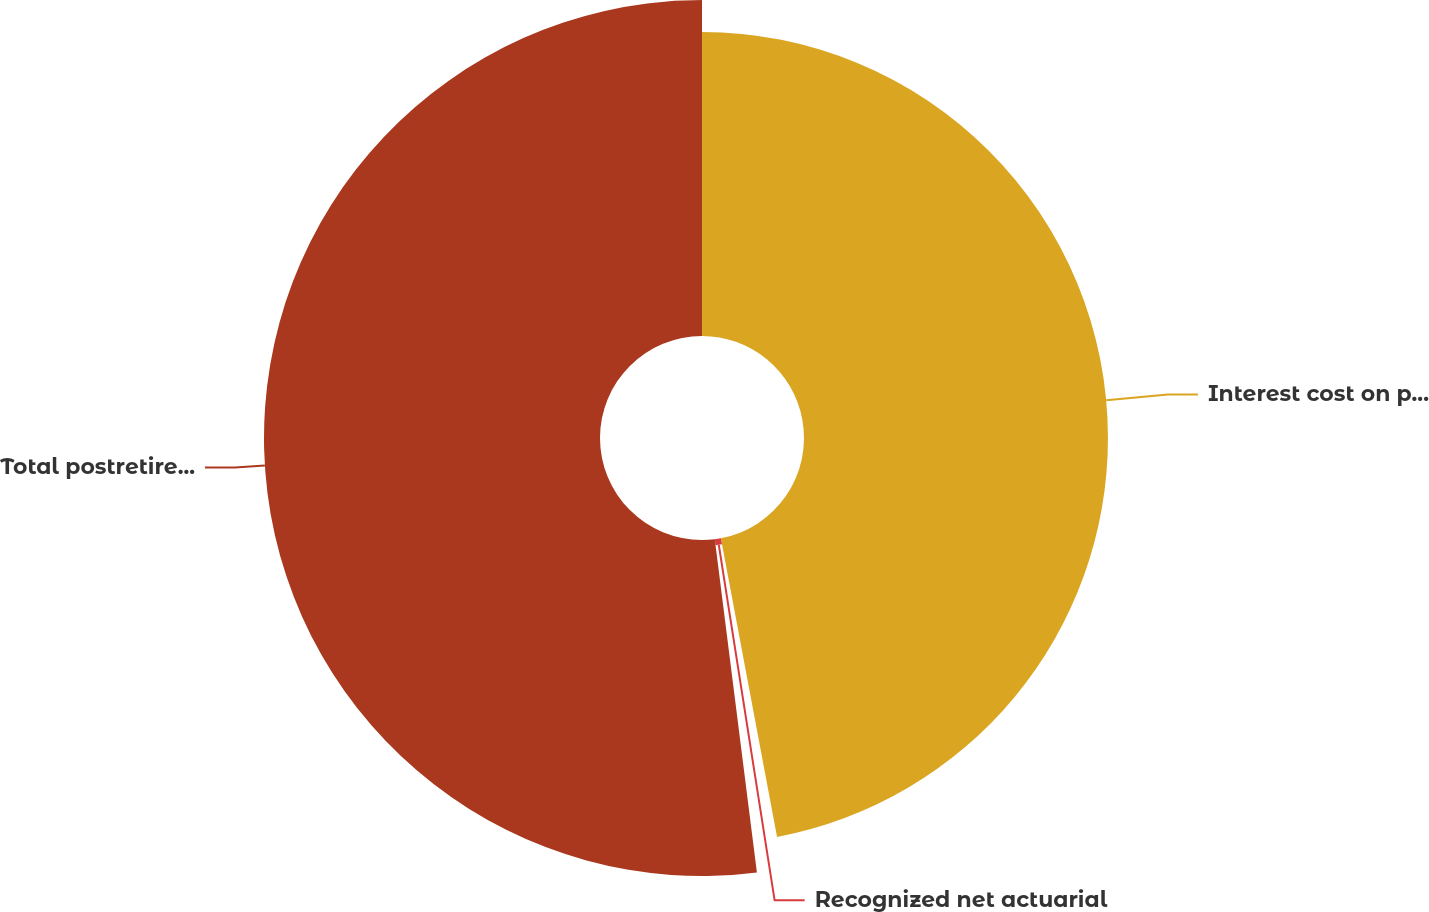Convert chart to OTSL. <chart><loc_0><loc_0><loc_500><loc_500><pie_chart><fcel>Interest cost on projected<fcel>Recognized net actuarial<fcel>Total postretirement benefit<nl><fcel>47.04%<fcel>0.96%<fcel>52.0%<nl></chart> 